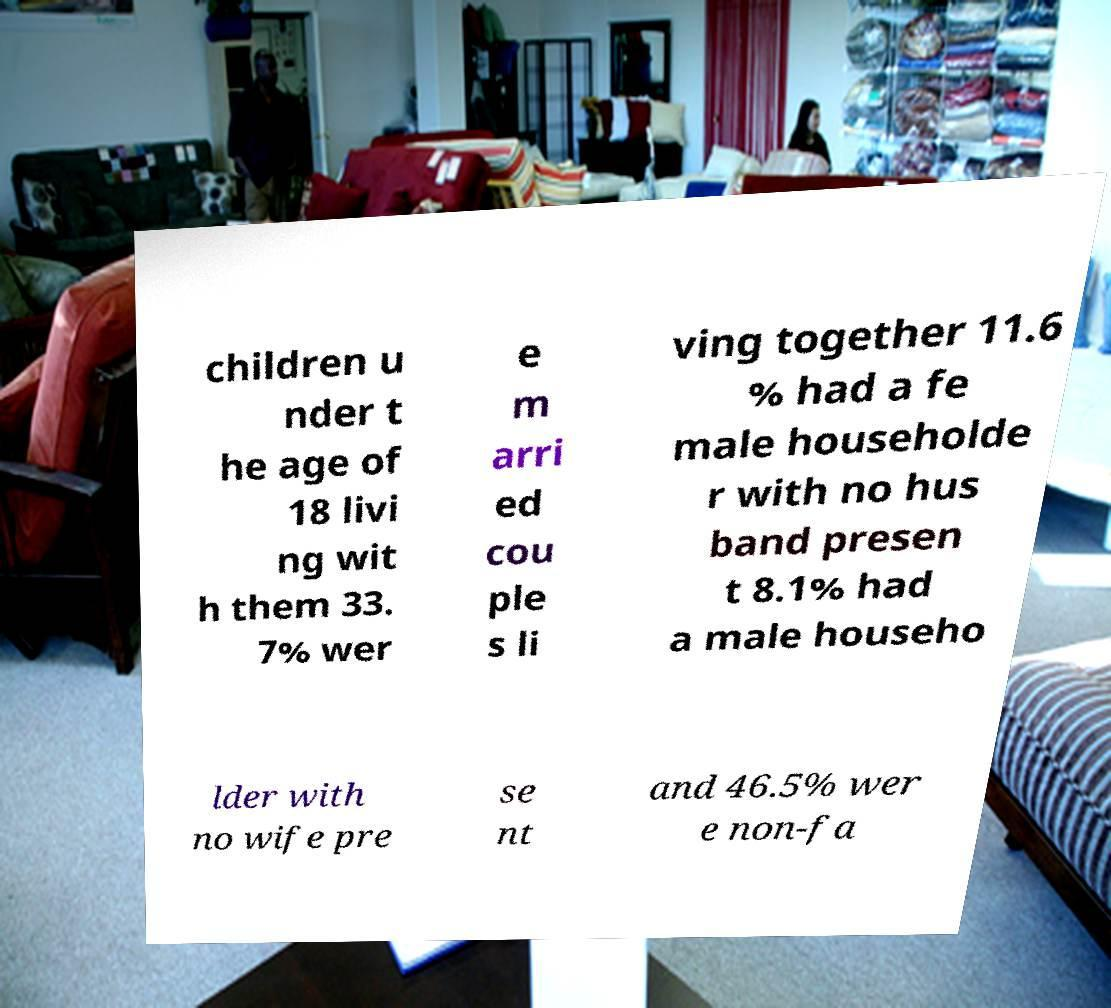Could you extract and type out the text from this image? children u nder t he age of 18 livi ng wit h them 33. 7% wer e m arri ed cou ple s li ving together 11.6 % had a fe male householde r with no hus band presen t 8.1% had a male househo lder with no wife pre se nt and 46.5% wer e non-fa 